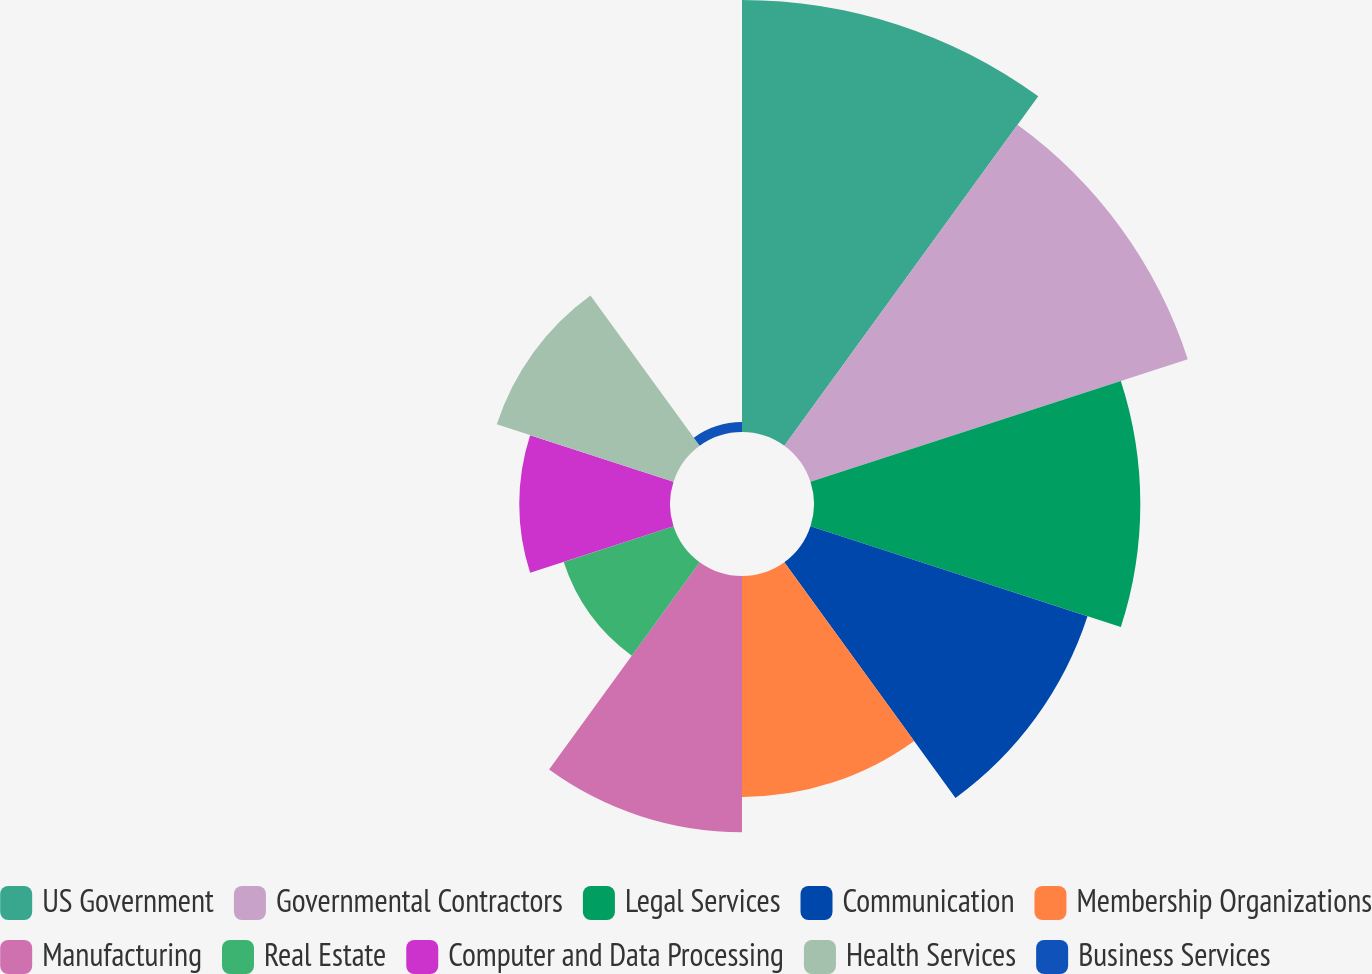Convert chart. <chart><loc_0><loc_0><loc_500><loc_500><pie_chart><fcel>US Government<fcel>Governmental Contractors<fcel>Legal Services<fcel>Communication<fcel>Membership Organizations<fcel>Manufacturing<fcel>Real Estate<fcel>Computer and Data Processing<fcel>Health Services<fcel>Business Services<nl><fcel>18.11%<fcel>16.63%<fcel>13.68%<fcel>12.21%<fcel>9.26%<fcel>10.74%<fcel>4.84%<fcel>6.32%<fcel>7.79%<fcel>0.42%<nl></chart> 